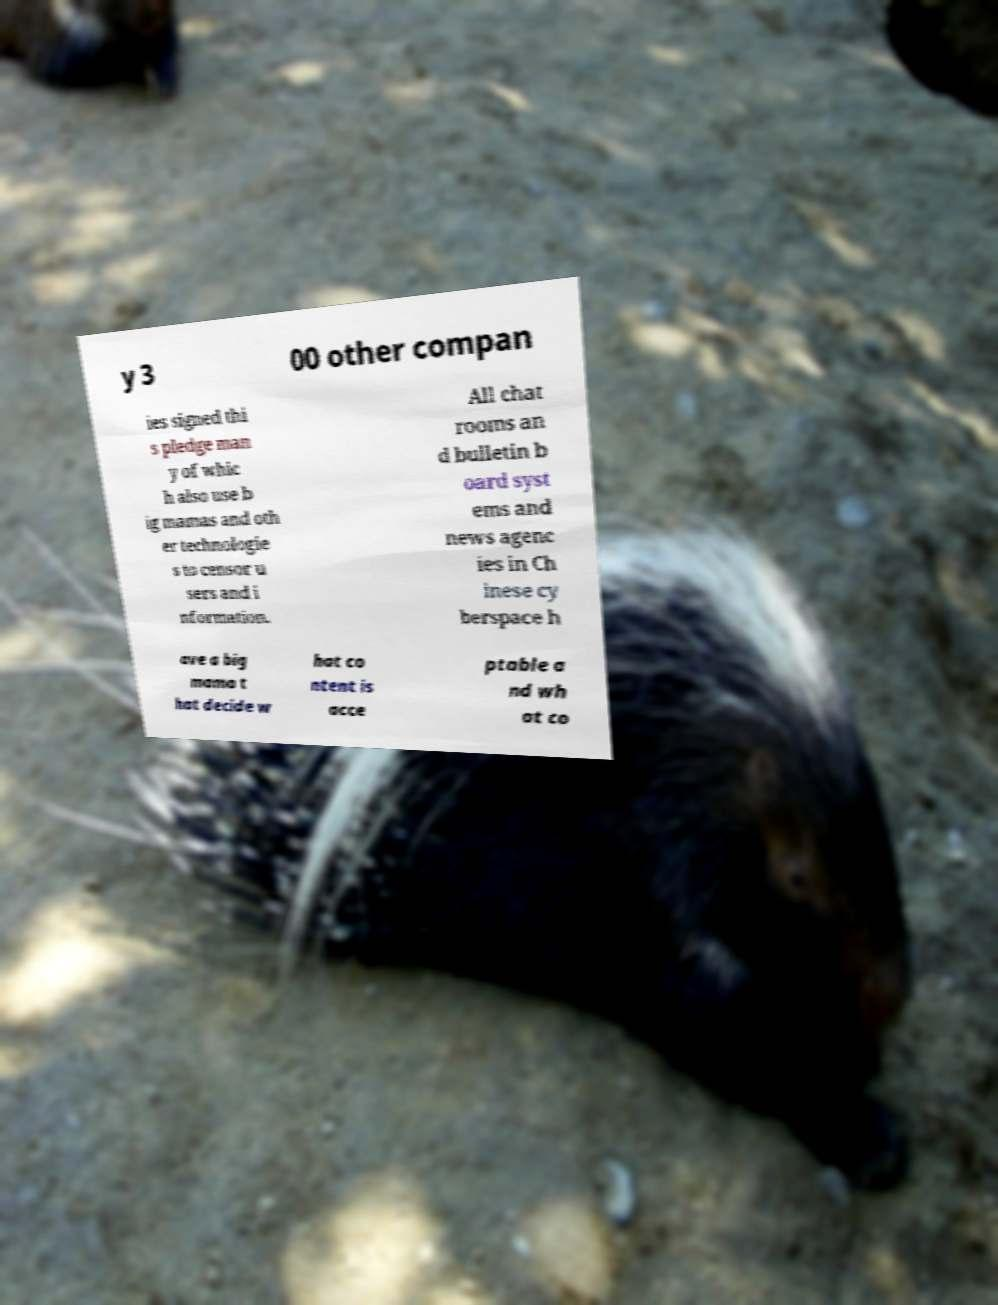Can you accurately transcribe the text from the provided image for me? y 3 00 other compan ies signed thi s pledge man y of whic h also use b ig mamas and oth er technologie s to censor u sers and i nformation. All chat rooms an d bulletin b oard syst ems and news agenc ies in Ch inese cy berspace h ave a big mama t hat decide w hat co ntent is acce ptable a nd wh at co 